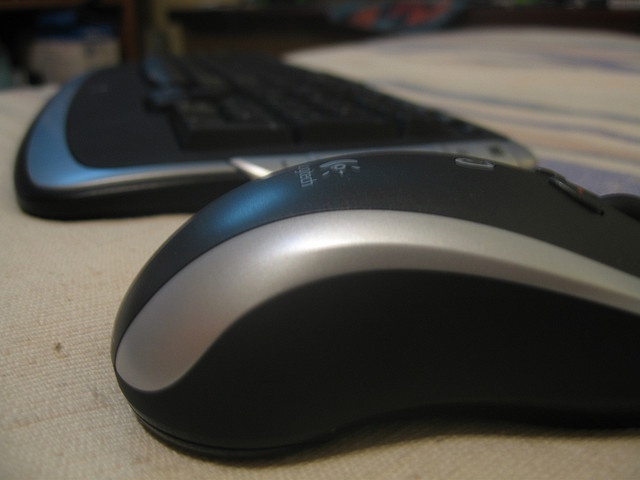Describe the objects in this image and their specific colors. I can see mouse in black, gray, and darkgray tones and keyboard in black, gray, and blue tones in this image. 